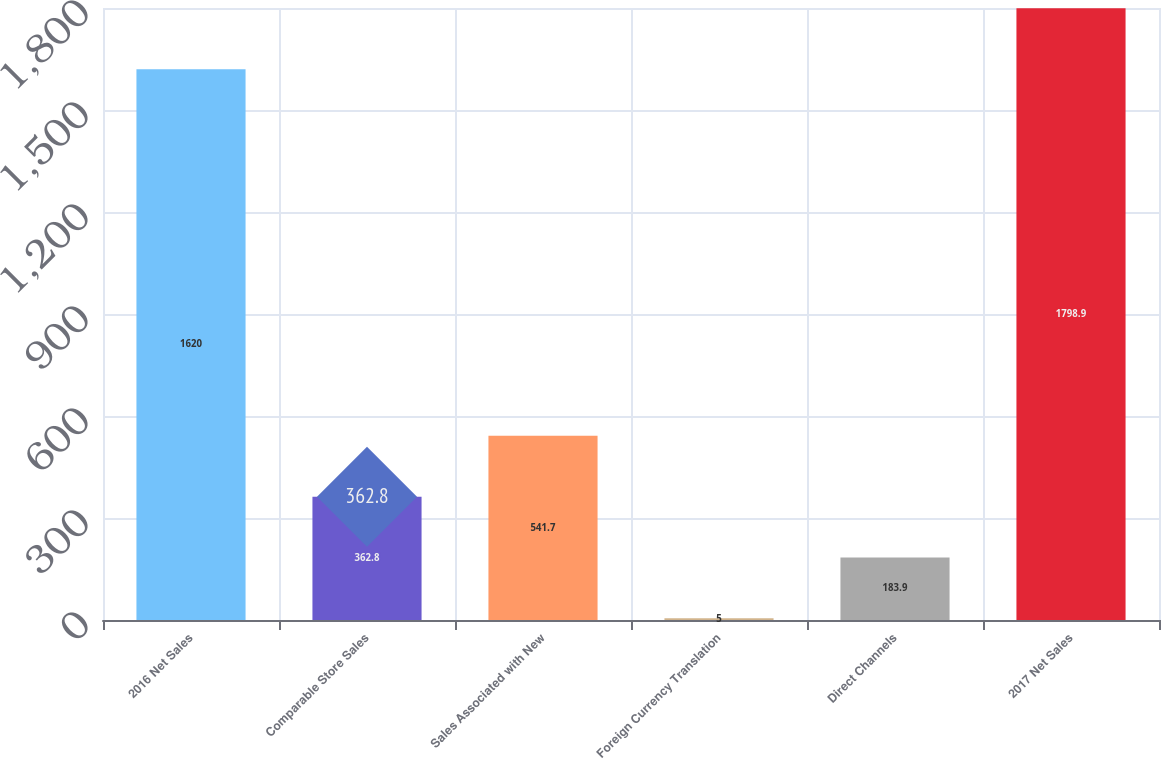Convert chart to OTSL. <chart><loc_0><loc_0><loc_500><loc_500><bar_chart><fcel>2016 Net Sales<fcel>Comparable Store Sales<fcel>Sales Associated with New<fcel>Foreign Currency Translation<fcel>Direct Channels<fcel>2017 Net Sales<nl><fcel>1620<fcel>362.8<fcel>541.7<fcel>5<fcel>183.9<fcel>1798.9<nl></chart> 